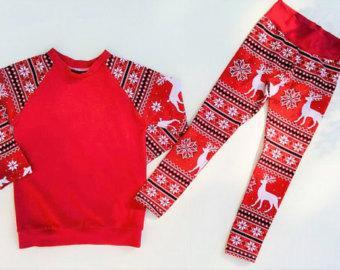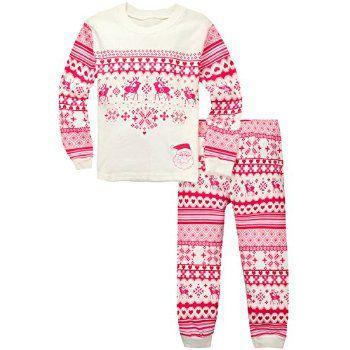The first image is the image on the left, the second image is the image on the right. Given the left and right images, does the statement "One image shows a mostly white top paired with red pants that have white polka dots." hold true? Answer yes or no. No. 